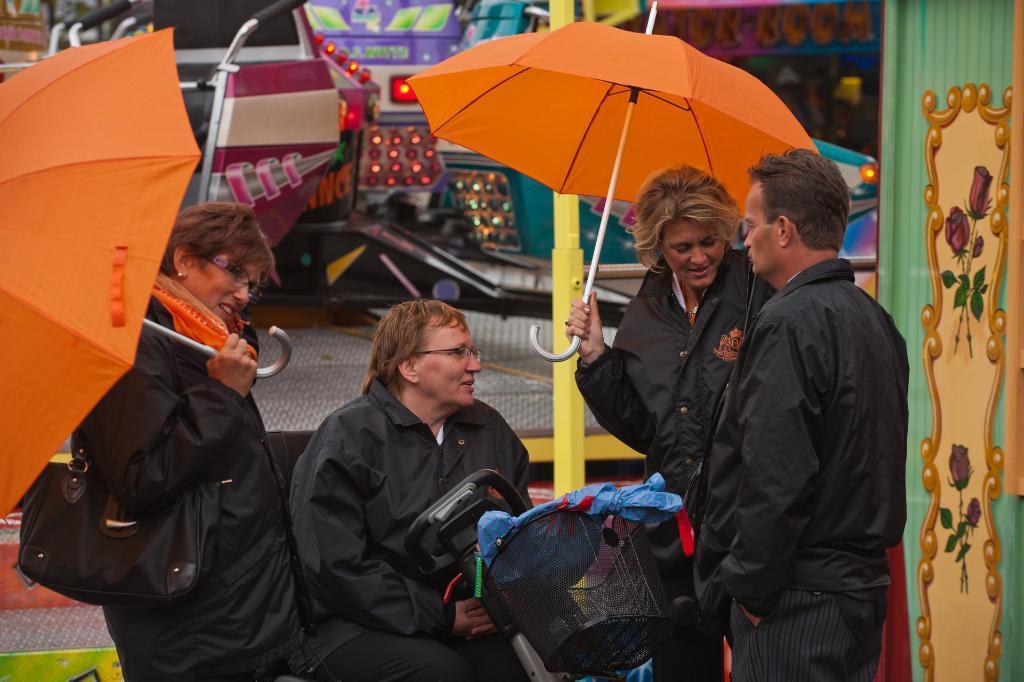Could you give a brief overview of what you see in this image? In this picture we can see a group of persons,some persons are holding umbrellas and in the background we can see some objects. 